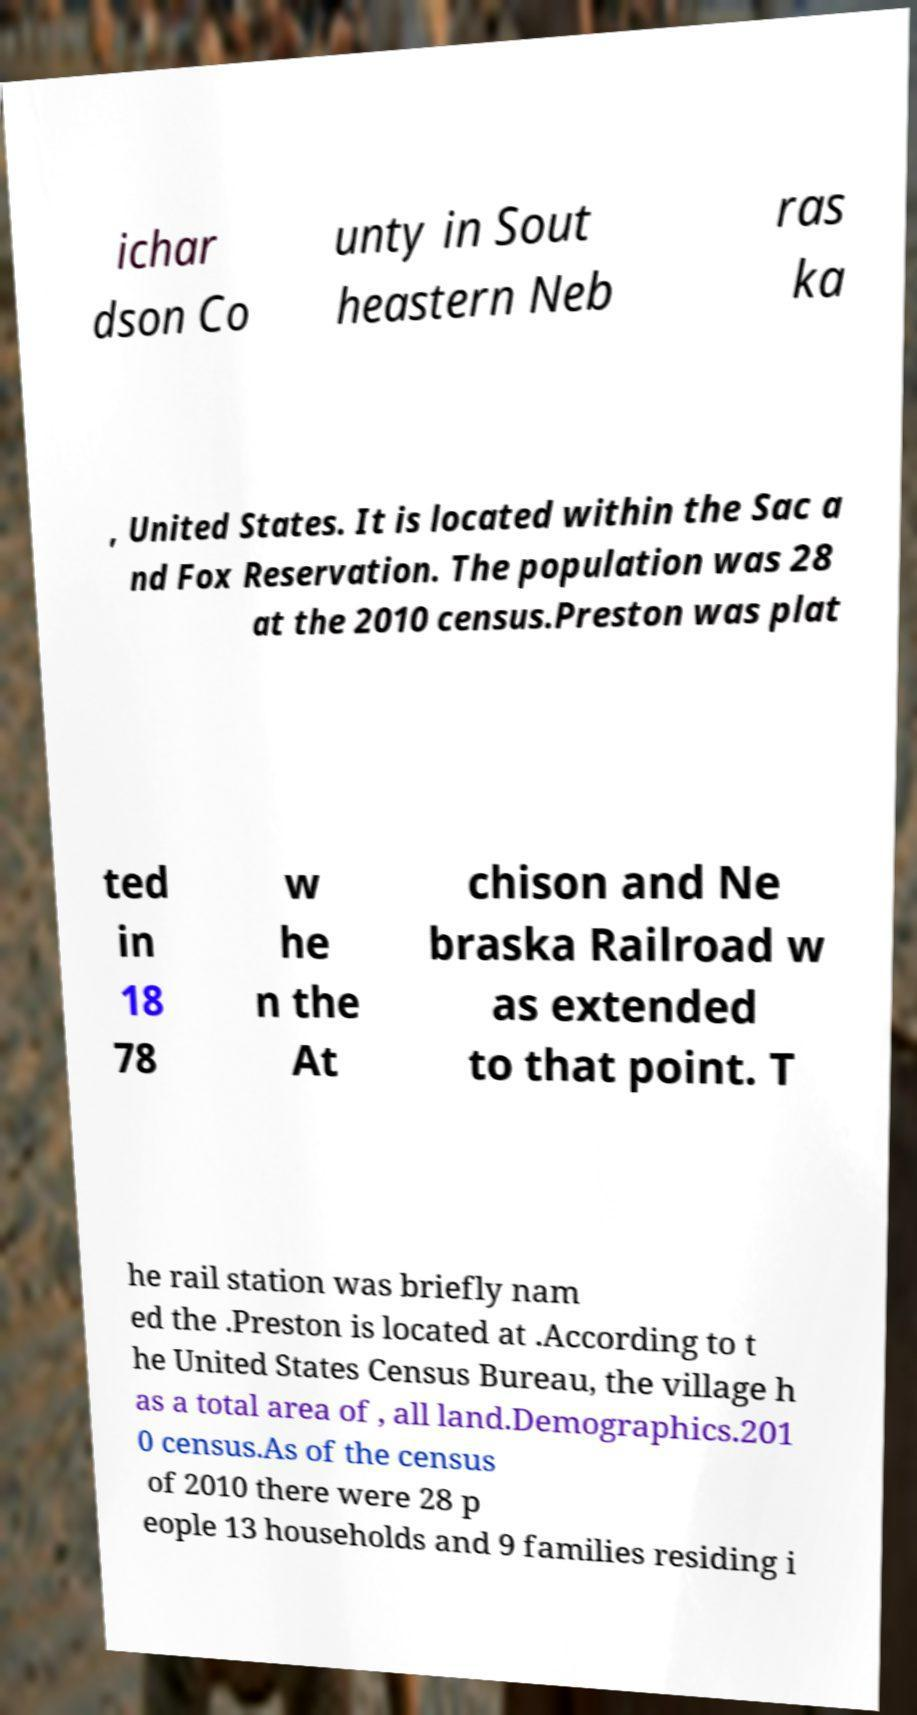What messages or text are displayed in this image? I need them in a readable, typed format. ichar dson Co unty in Sout heastern Neb ras ka , United States. It is located within the Sac a nd Fox Reservation. The population was 28 at the 2010 census.Preston was plat ted in 18 78 w he n the At chison and Ne braska Railroad w as extended to that point. T he rail station was briefly nam ed the .Preston is located at .According to t he United States Census Bureau, the village h as a total area of , all land.Demographics.201 0 census.As of the census of 2010 there were 28 p eople 13 households and 9 families residing i 